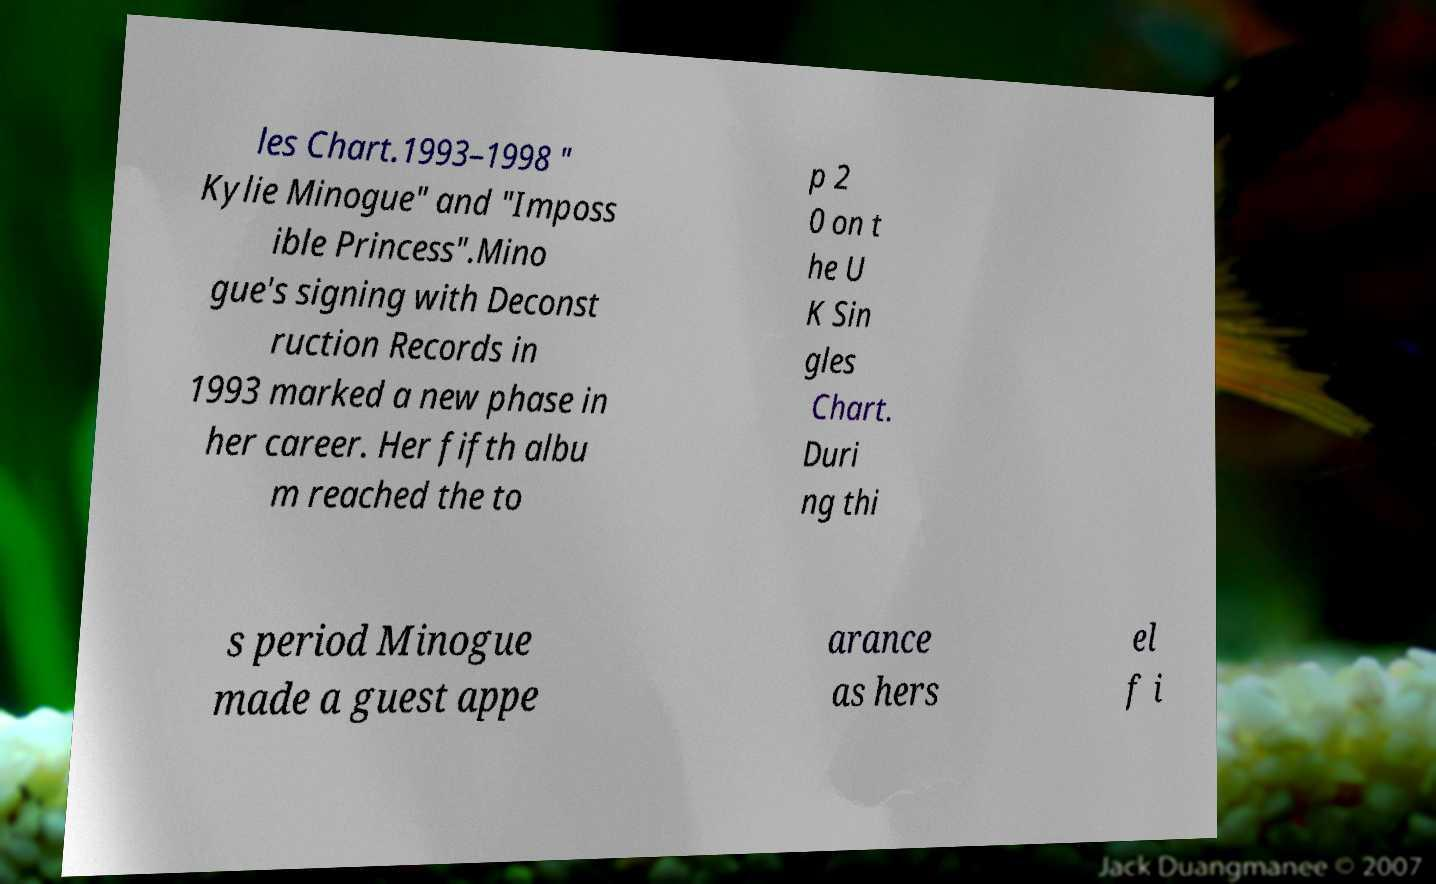For documentation purposes, I need the text within this image transcribed. Could you provide that? les Chart.1993–1998 " Kylie Minogue" and "Imposs ible Princess".Mino gue's signing with Deconst ruction Records in 1993 marked a new phase in her career. Her fifth albu m reached the to p 2 0 on t he U K Sin gles Chart. Duri ng thi s period Minogue made a guest appe arance as hers el f i 